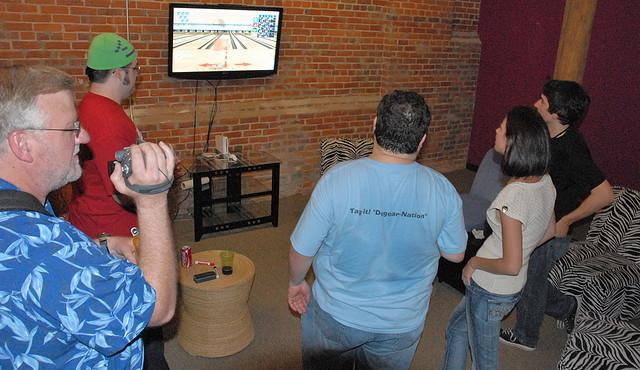Which Wii sport game must be played by the crowd of children in the lounge? bowling 